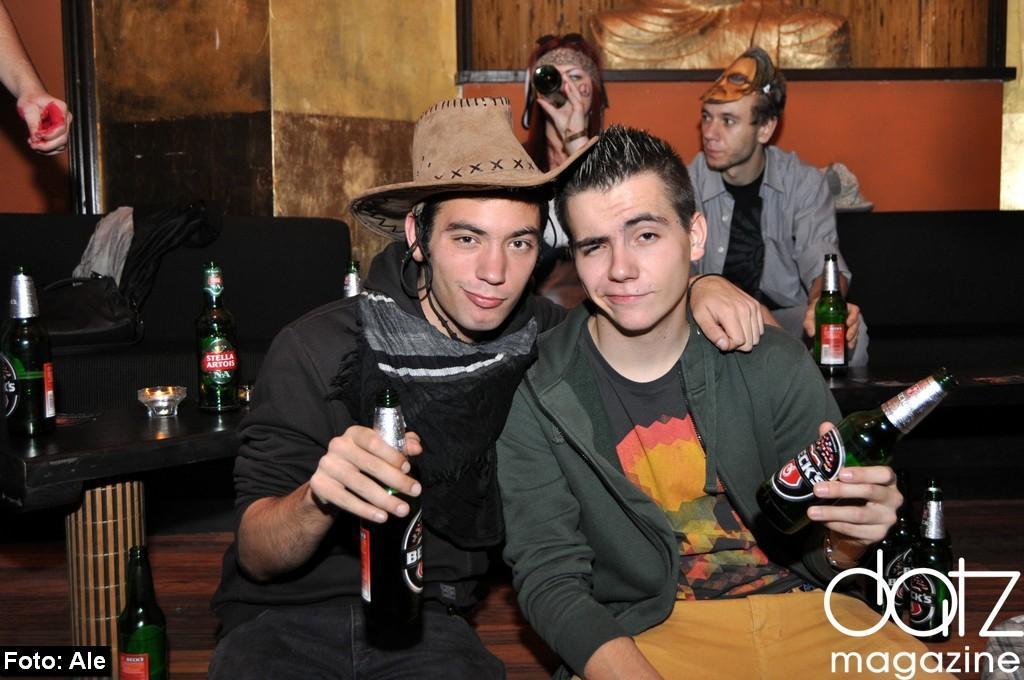Can you describe this image briefly? There are two members in this picture, holding a wine bottles in their hands. One of the guy is wearing a hat. In the background there are two other people sitting in the sofas. There is a photo frame attached to the wall in the background. 